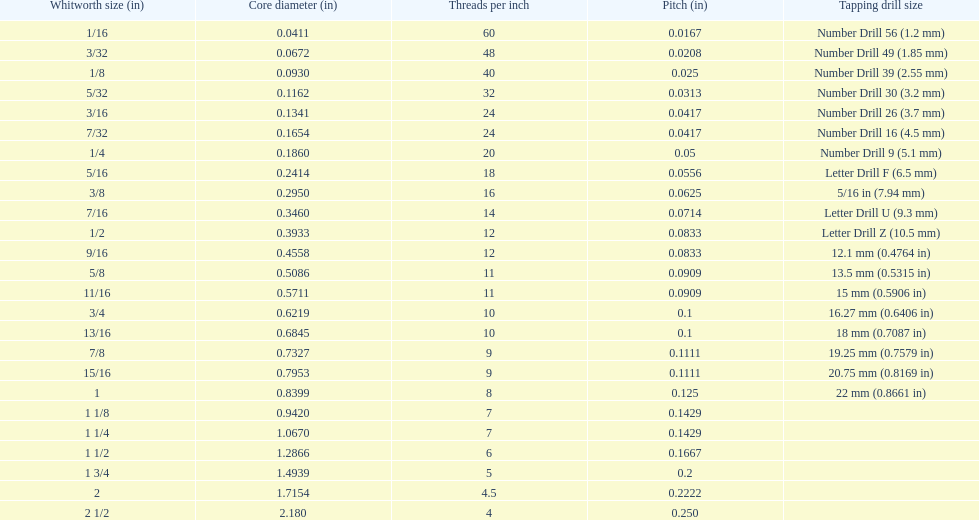What is the top amount of threads per inch? 60. 